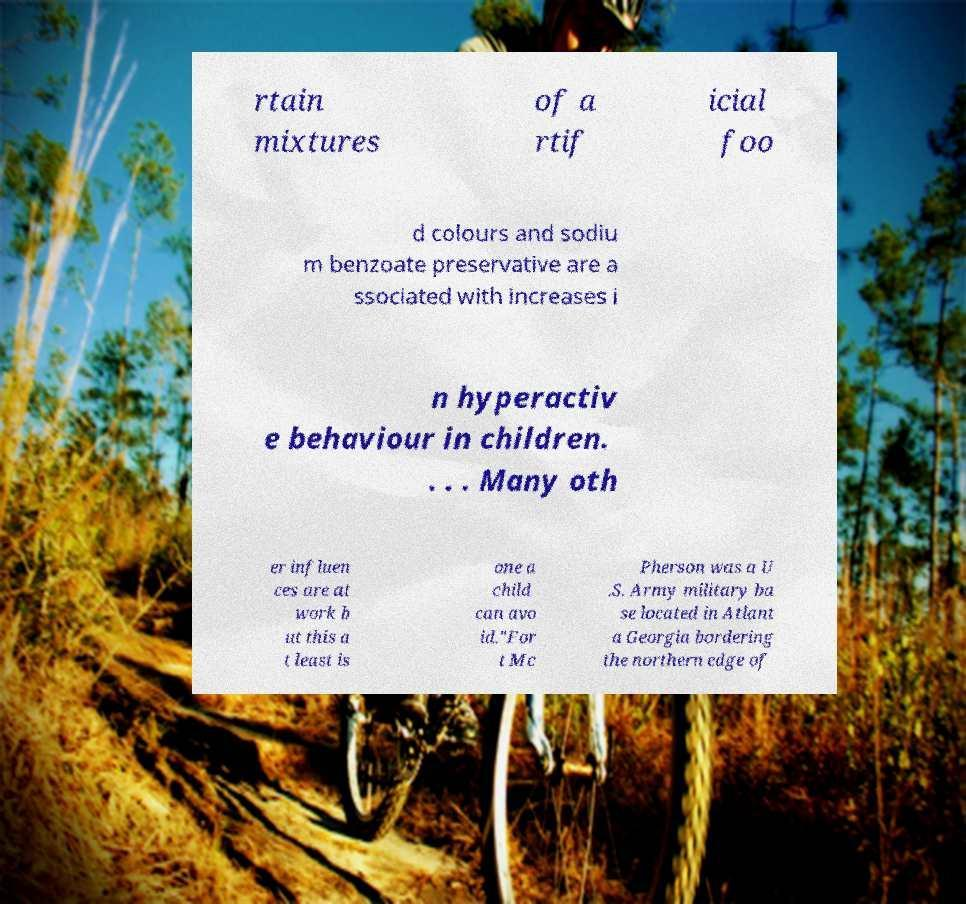I need the written content from this picture converted into text. Can you do that? rtain mixtures of a rtif icial foo d colours and sodiu m benzoate preservative are a ssociated with increases i n hyperactiv e behaviour in children. . . . Many oth er influen ces are at work b ut this a t least is one a child can avo id."For t Mc Pherson was a U .S. Army military ba se located in Atlant a Georgia bordering the northern edge of 